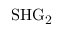<formula> <loc_0><loc_0><loc_500><loc_500>S H G _ { 2 }</formula> 